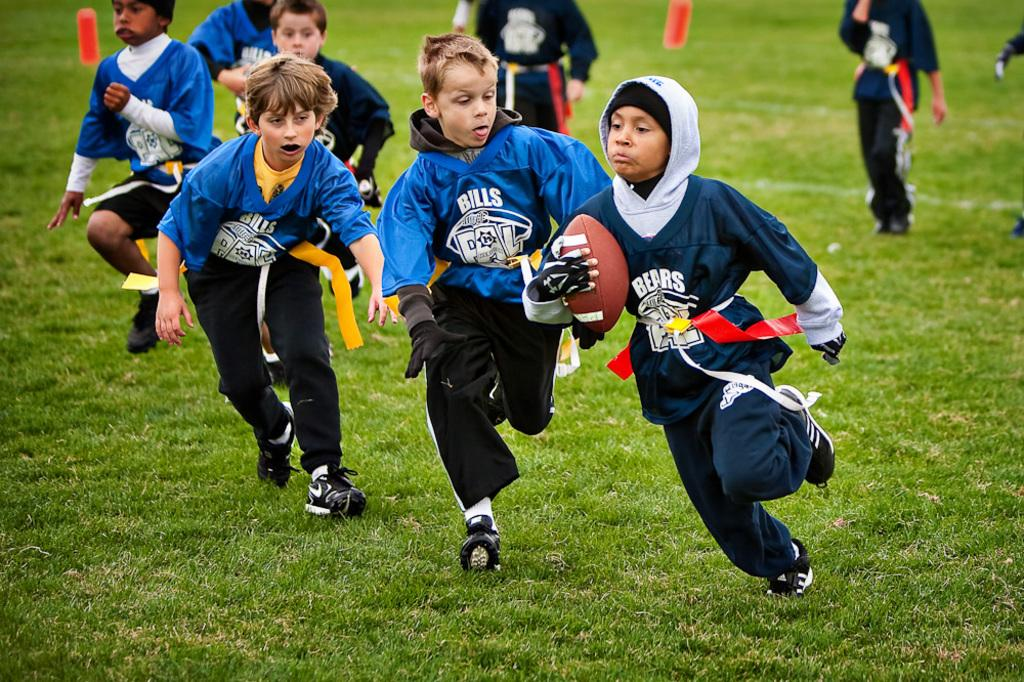<image>
Describe the image concisely. Kids playing football one is on the team bills and the other is on the bears. 